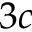<formula> <loc_0><loc_0><loc_500><loc_500>3 c</formula> 